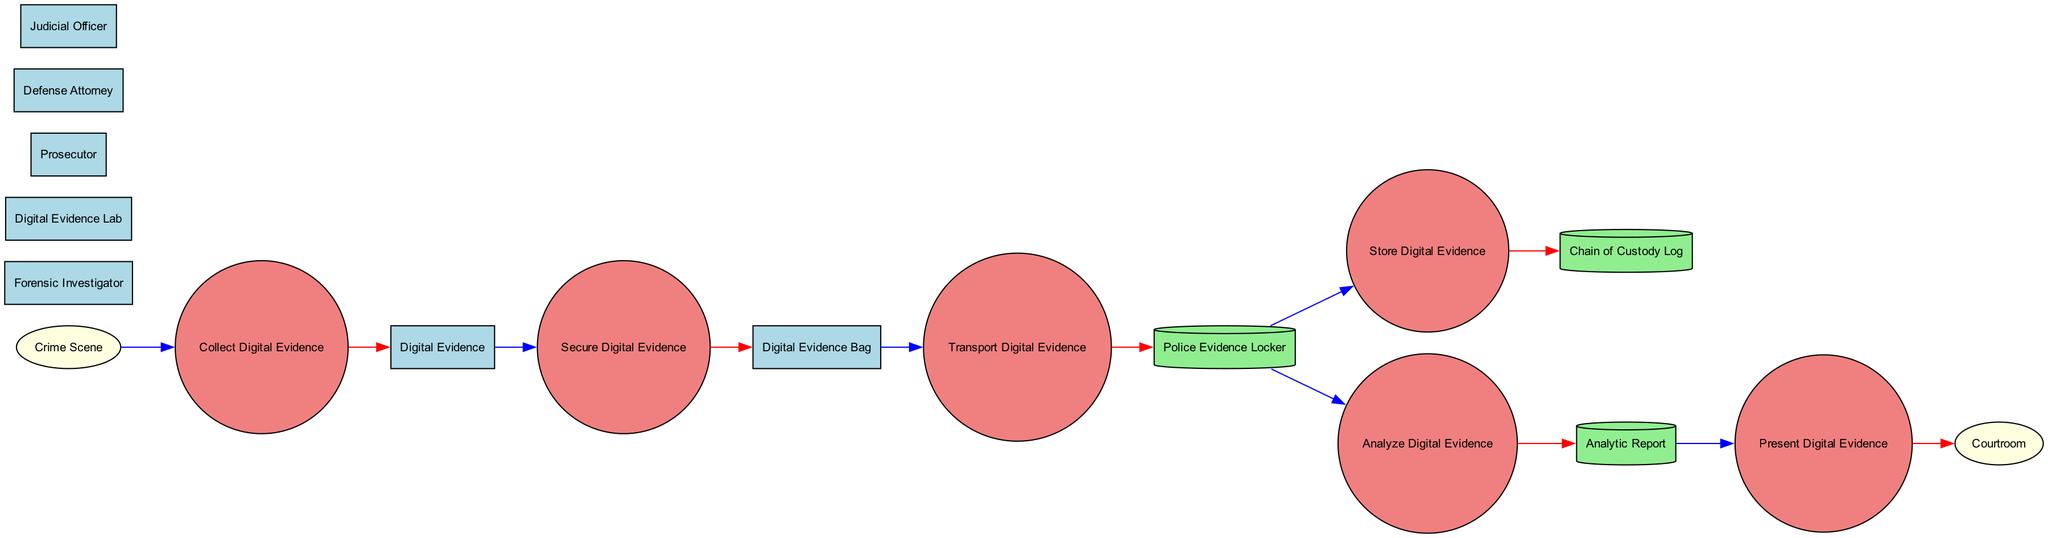What is the initial source of digital evidence? The diagram identifies "Crime Scene" as the initial source where digital evidence is collected.
Answer: Crime Scene What process follows the collection of digital evidence? After the "Collect Digital Evidence" process, the next step is "Secure Digital Evidence" as shown in the diagram.
Answer: Secure Digital Evidence How many processes are involved in handling digital evidence? The diagram lists six processes: "Collect Digital Evidence," "Secure Digital Evidence," "Transport Digital Evidence," "Store Digital Evidence," "Analyze Digital Evidence," and "Present Digital Evidence." Therefore, the total is six processes.
Answer: Six What is the shape used to represent data stores in the diagram? The diagram uses a cylinder shape to represent data stores. This can be observed from the node representations.
Answer: Cylinder Which entity is responsible for analyzing digital evidence? The "Digital Evidence Lab" is explicitly labeled in the diagram as the facility where digital forensic analysis is performed, indicating its responsibility in analyzing digital evidence.
Answer: Digital Evidence Lab In what container is digital evidence secured for transport? Digital evidence is placed in a "Digital Evidence Bag," which is a secure container mentioned in the diagram.
Answer: Digital Evidence Bag What is documented in the Chain of Custody Log? The Chain of Custody Log records the control, transfer, and analysis of digital evidence, ensuring the integrity of the evidence throughout the process.
Answer: Control, transfer, and analysis Who presents the analyzed digital evidence in court? The diagram indicates that the "Prosecutor" is the legal professional responsible for presenting the evidence during the trial.
Answer: Prosecutor What is the end point where digital evidence is presented? The diagram clearly states that the "Courtroom" is the endpoint where analyzed digital evidence is presented during legal proceedings.
Answer: Courtroom 